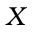<formula> <loc_0><loc_0><loc_500><loc_500>X</formula> 